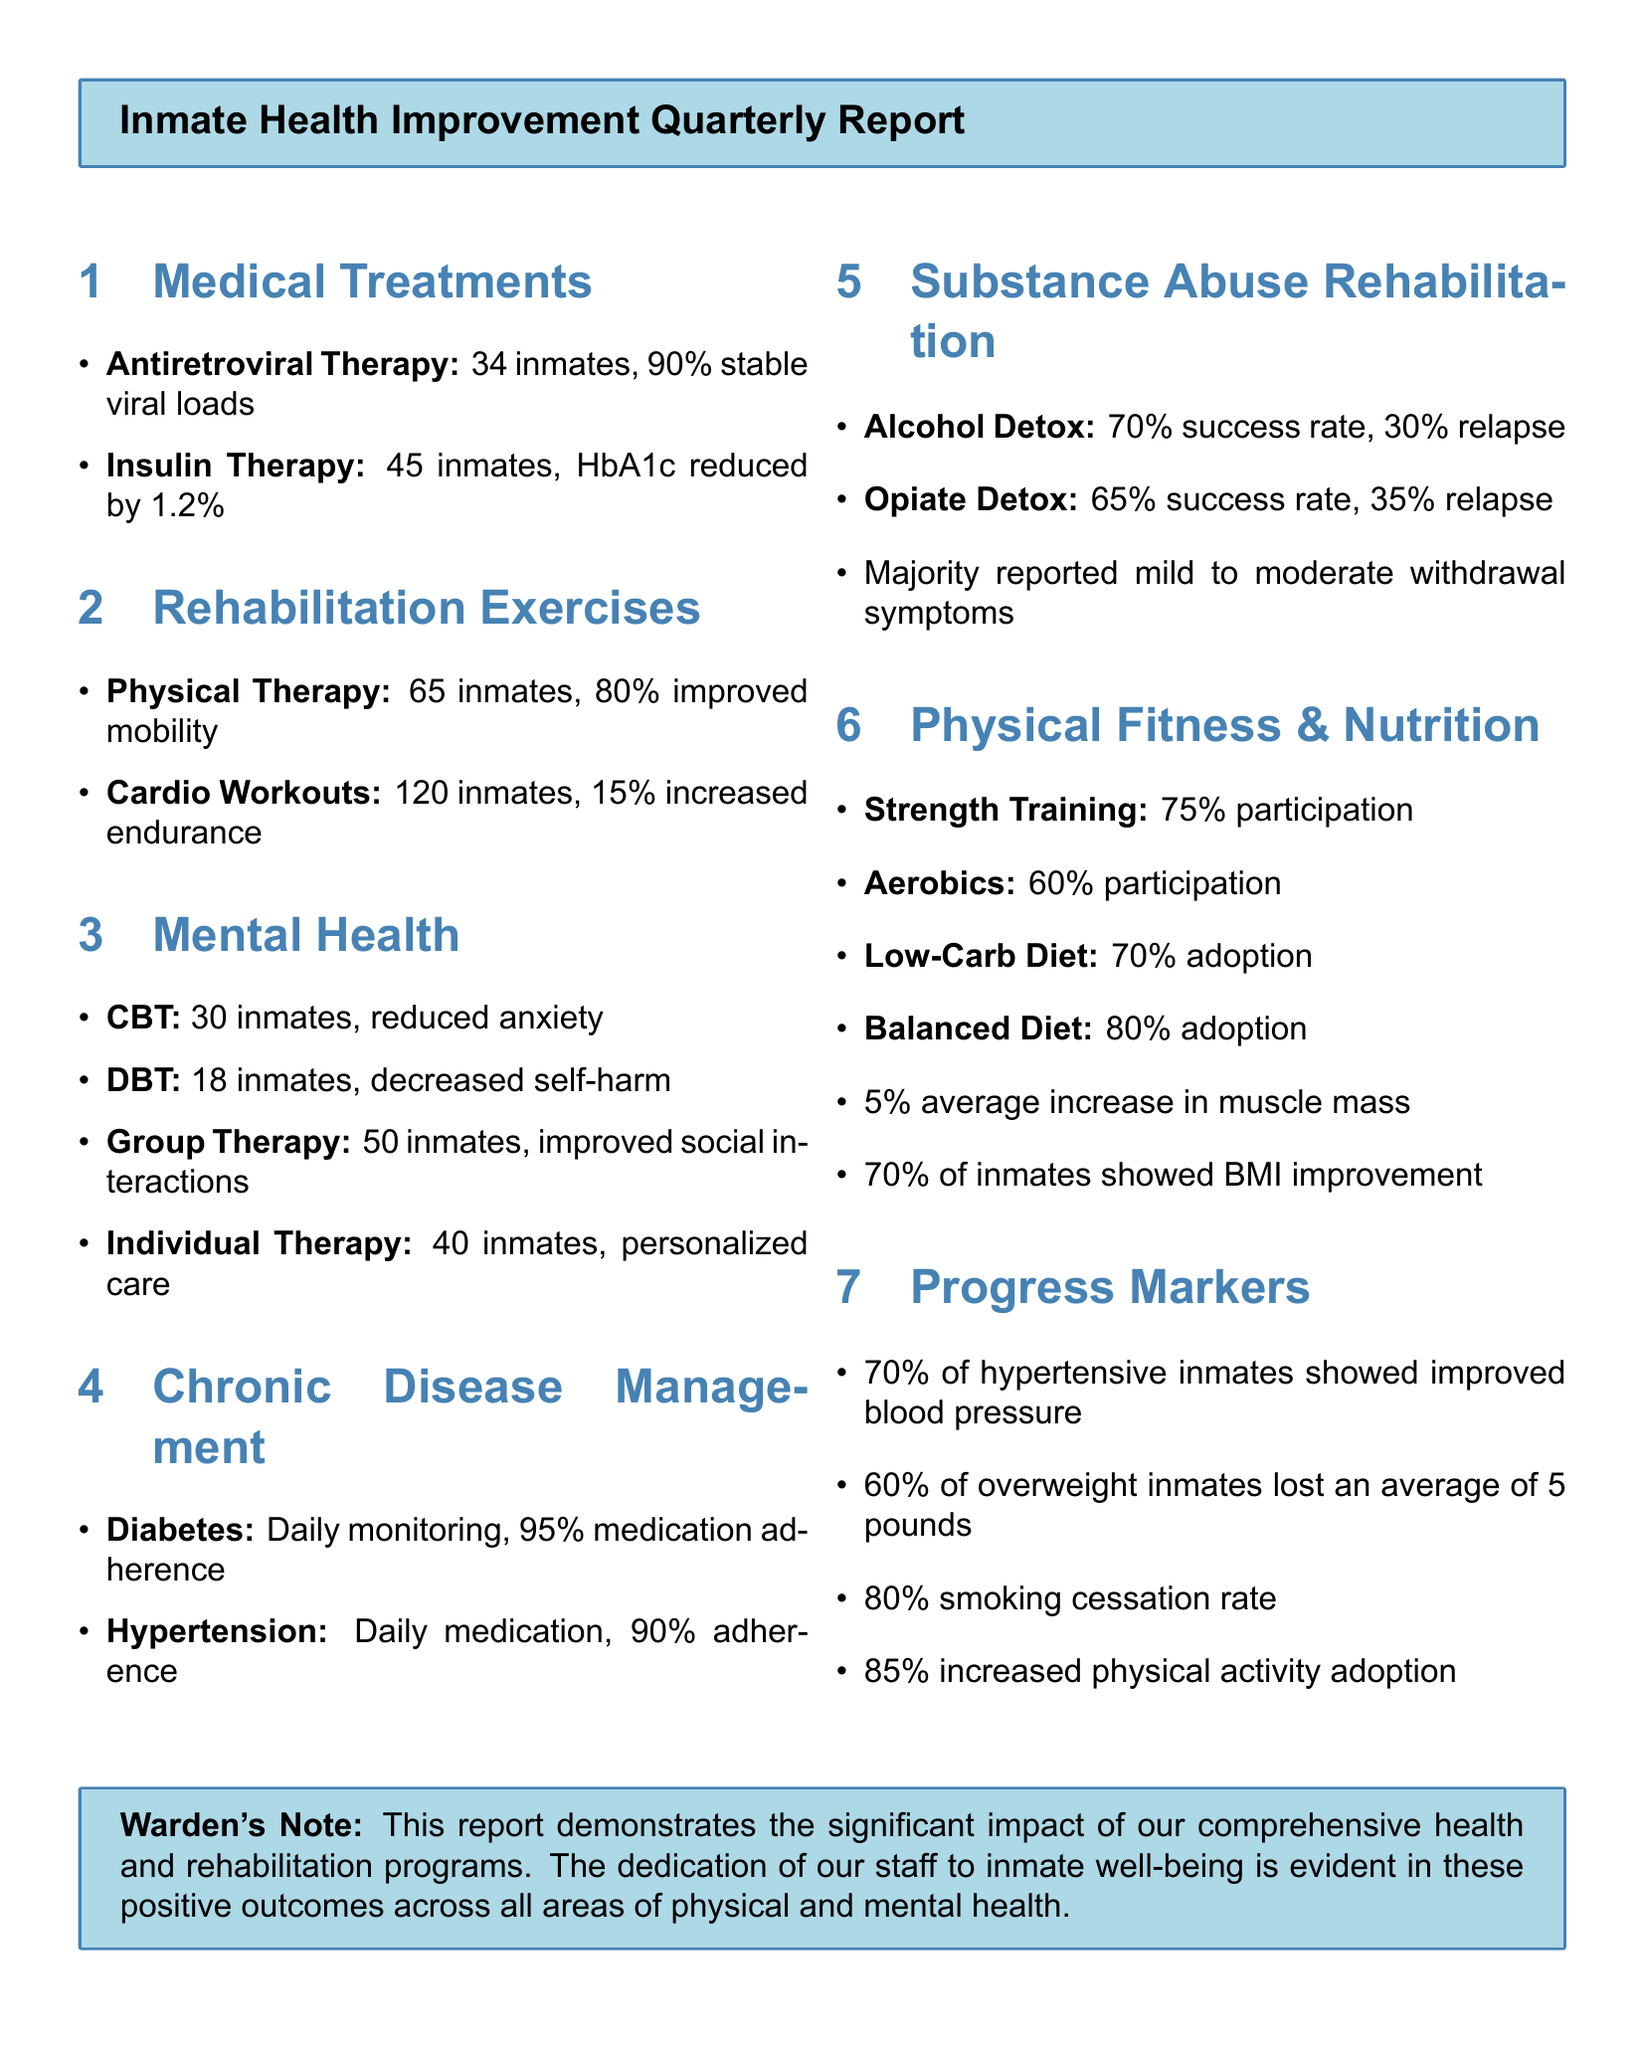What is the success rate for Alcohol Detox? The success rate is specified in the document for Alcohol Detox, which is stated as 70%.
Answer: 70% How many inmates participated in Cardio Workouts? The document indicates that 120 inmates participated in Cardio Workouts, making it a specific metric of engagement.
Answer: 120 inmates What percentage of diabetic inmates demonstrated medication adherence? The document presents that there is a 95% medication adherence among diabetic inmates, reflecting their management effectiveness.
Answer: 95% What is the average weight loss for overweight inmates? The document mentions that overweight inmates lost an average of 5 pounds, indicating a measurable health outcome.
Answer: 5 pounds How many inmates showed improved mobility through Physical Therapy? The document specifies that 65 inmates improved their mobility, which indicates the effectiveness of the program.
Answer: 65 inmates What percentage of inmates adopted a Balanced Diet? The Balanced Diet adoption rate is noted as 80% in the document, highlighting dietary improvements.
Answer: 80% Which therapy showed the highest participation among inmates? The document lists Group Therapy as having the highest number of participants at 50 inmates.
Answer: Group Therapy How many inmates were involved in Individual Therapy sessions? The document states that 40 inmates were involved in Individual Therapy sessions, indicating the level of personalized care being provided.
Answer: 40 inmates What drug treatment had a 65% success rate? The document indicates Opiate Detox has a success rate of 65%, specifying the outcomes of substance abuse rehabilitation.
Answer: Opiate Detox 